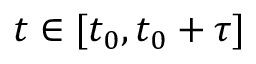<formula> <loc_0><loc_0><loc_500><loc_500>t \in [ t _ { 0 } , t _ { 0 } + \tau ]</formula> 